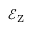<formula> <loc_0><loc_0><loc_500><loc_500>\mathcal { E } _ { Z }</formula> 